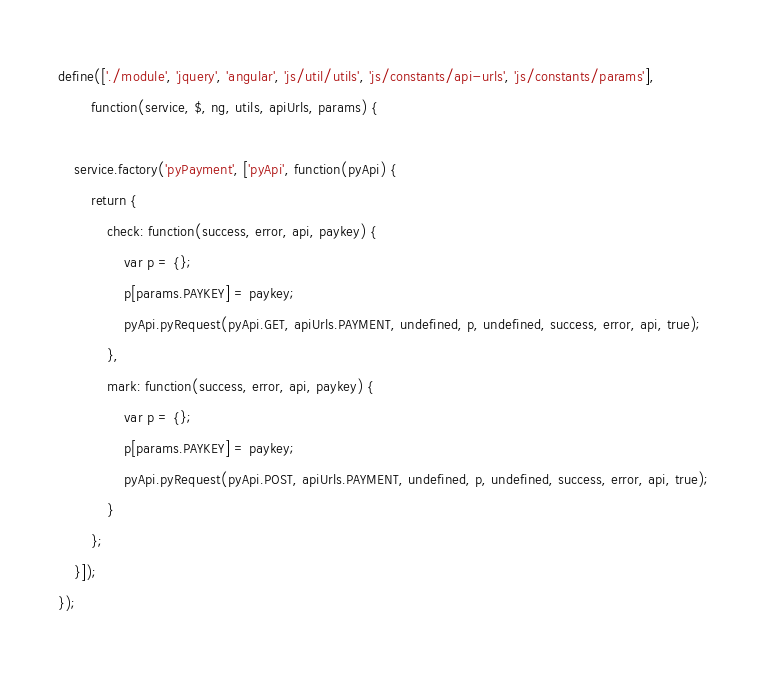Convert code to text. <code><loc_0><loc_0><loc_500><loc_500><_JavaScript_>define(['./module', 'jquery', 'angular', 'js/util/utils', 'js/constants/api-urls', 'js/constants/params'],
		function(service, $, ng, utils, apiUrls, params) {
	
	service.factory('pyPayment', ['pyApi', function(pyApi) {
		return {
			check: function(success, error, api, paykey) {
				var p = {};
				p[params.PAYKEY] = paykey;
				pyApi.pyRequest(pyApi.GET, apiUrls.PAYMENT, undefined, p, undefined, success, error, api, true);
			},
			mark: function(success, error, api, paykey) {
				var p = {};
				p[params.PAYKEY] = paykey;
				pyApi.pyRequest(pyApi.POST, apiUrls.PAYMENT, undefined, p, undefined, success, error, api, true);
			}
		};
	}]);
});</code> 